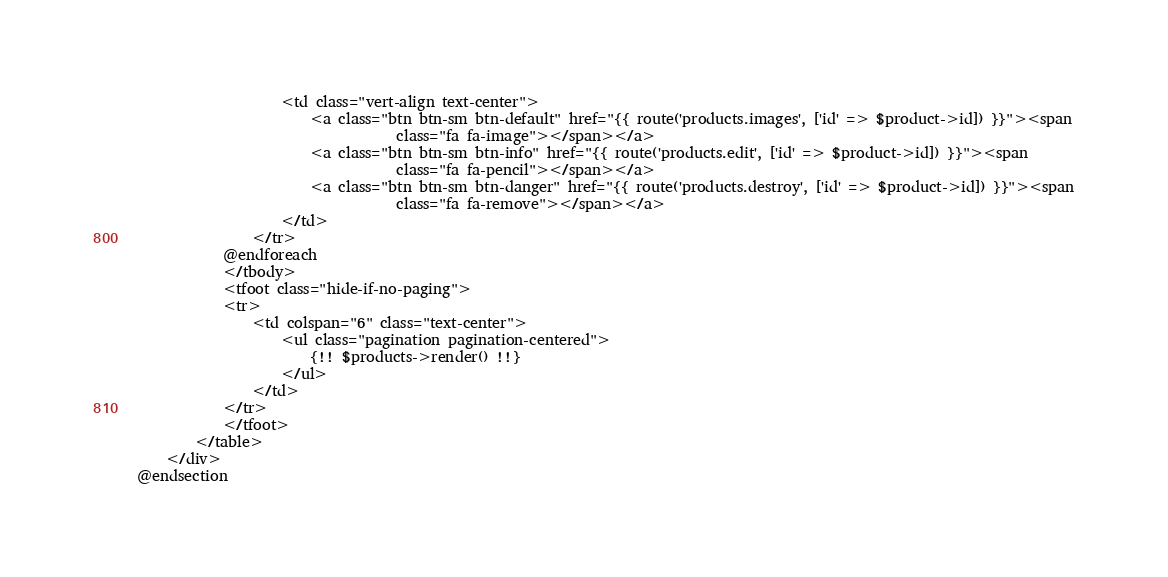Convert code to text. <code><loc_0><loc_0><loc_500><loc_500><_PHP_>                    <td class="vert-align text-center">
                        <a class="btn btn-sm btn-default" href="{{ route('products.images', ['id' => $product->id]) }}"><span
                                    class="fa fa-image"></span></a>
                        <a class="btn btn-sm btn-info" href="{{ route('products.edit', ['id' => $product->id]) }}"><span
                                    class="fa fa-pencil"></span></a>
                        <a class="btn btn-sm btn-danger" href="{{ route('products.destroy', ['id' => $product->id]) }}"><span
                                    class="fa fa-remove"></span></a>
                    </td>
                </tr>
            @endforeach
            </tbody>
            <tfoot class="hide-if-no-paging">
            <tr>
                <td colspan="6" class="text-center">
                    <ul class="pagination pagination-centered">
                        {!! $products->render() !!}
                    </ul>
                </td>
            </tr>
            </tfoot>
        </table>
    </div>
@endsection</code> 